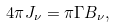Convert formula to latex. <formula><loc_0><loc_0><loc_500><loc_500>4 \pi J _ { \nu } = \pi \Gamma B _ { \nu } ,</formula> 